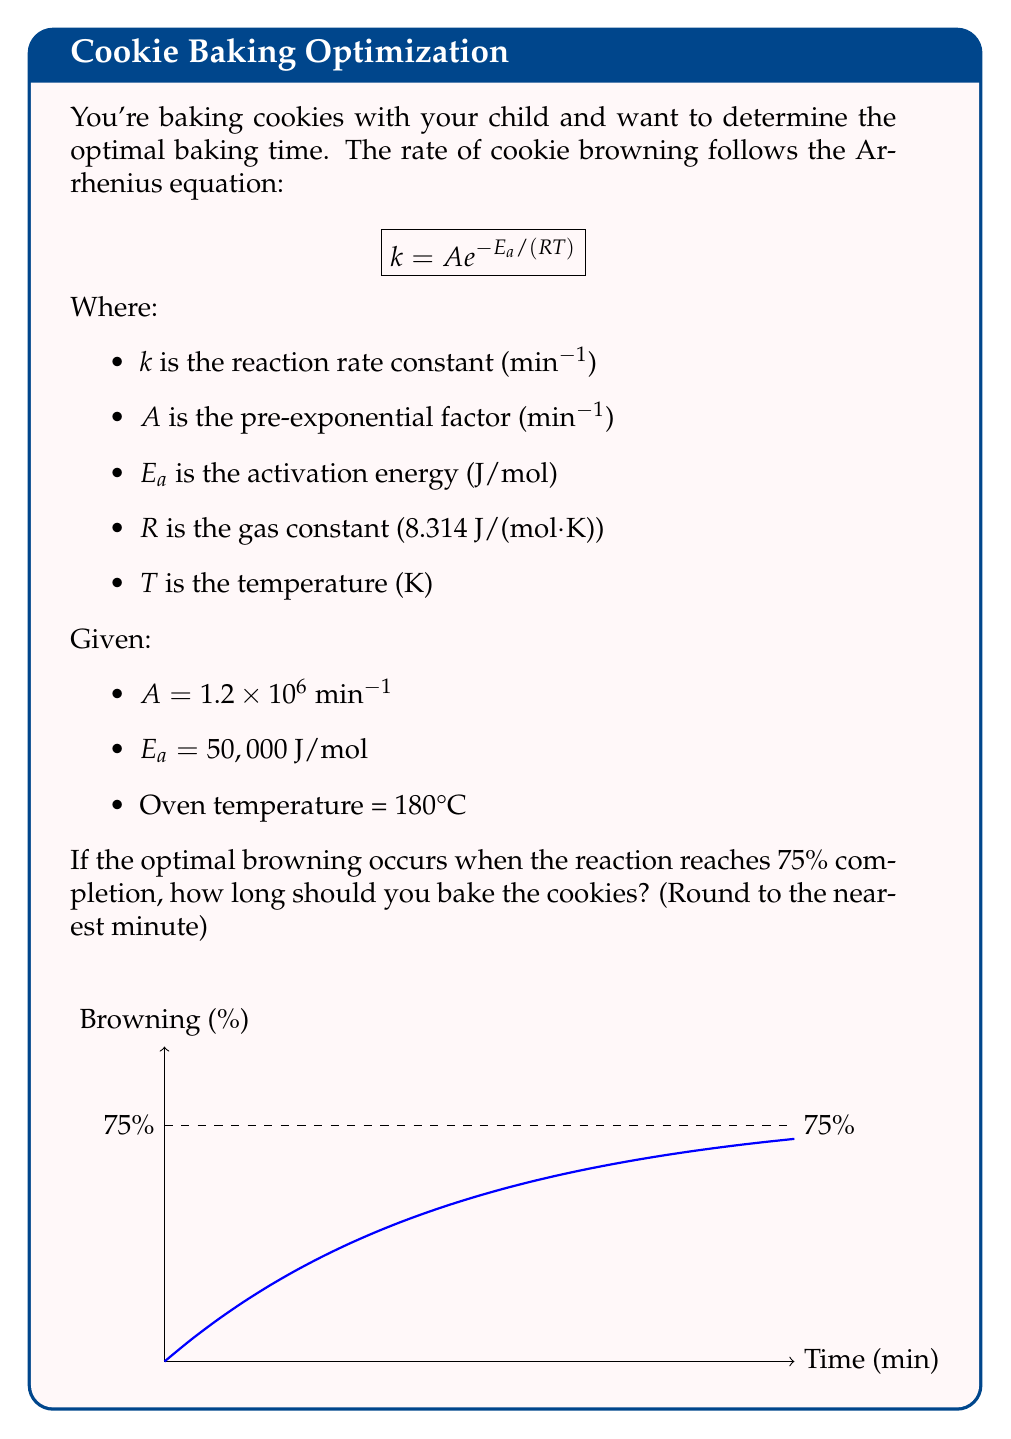Teach me how to tackle this problem. Let's approach this step-by-step:

1) First, we need to calculate the reaction rate constant $k$ using the Arrhenius equation:

   $$k = A e^{-E_a / (RT)}$$

2) Convert the oven temperature from Celsius to Kelvin:
   $T = 180°C + 273.15 = 453.15$ K

3) Plug in the values:
   $$k = 1.2 \times 10^6 \cdot e^{-50,000 / (8.314 \cdot 453.15)}$$

4) Calculate $k$:
   $$k \approx 0.215 \text{ min}^{-1}$$

5) The rate equation for a first-order reaction is:
   $$\ln(1-x) = -kt$$
   Where $x$ is the fraction of completion and $t$ is time.

6) We want 75% completion, so $x = 0.75$. Solve for $t$:
   $$\ln(1-0.75) = -0.215t$$
   $$-1.386 = -0.215t$$
   $$t = 6.45 \text{ minutes}$$

7) Rounding to the nearest minute:
   $t \approx 6 \text{ minutes}$
Answer: 6 minutes 